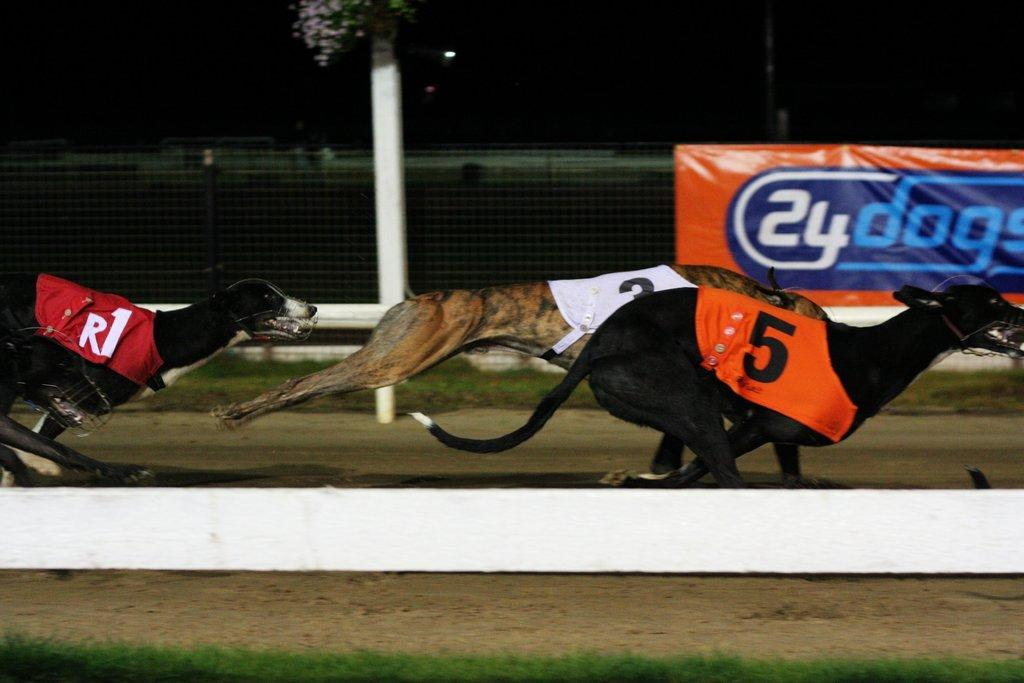What animals are present in the image? There are dogs in the image. What are the dogs doing in the image? The dogs are running. Are the dogs wearing any clothing in the image? Yes, the dogs have clothes on them. What type of barrier can be seen in the image? There is a metal fence in the image. What is the tall, vertical object in the image? There is a pole in the image. What type of ground surface is visible in the image? Grass is visible on the ground in the image. What type of treatment is being administered to the dogs in the image? There is no indication in the image that the dogs are receiving any treatment. 